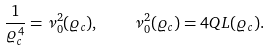<formula> <loc_0><loc_0><loc_500><loc_500>\frac { 1 } { \varrho _ { c } ^ { 4 } } = \nu _ { 0 } ^ { 2 } ( \varrho _ { c } ) , \quad \nu _ { 0 } ^ { 2 } ( \varrho _ { c } ) = 4 Q L ( \varrho _ { c } ) .</formula> 